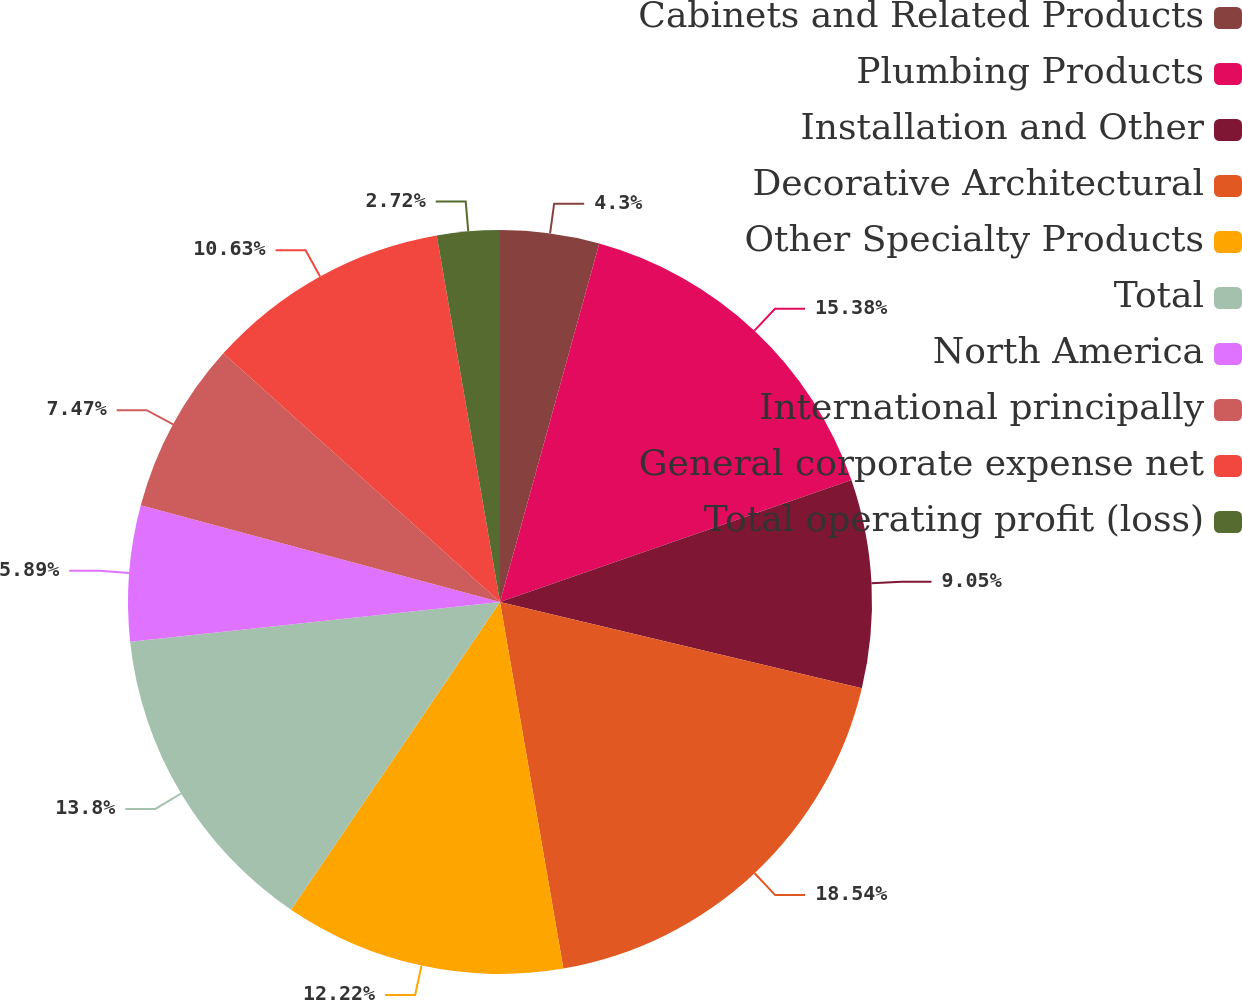Convert chart to OTSL. <chart><loc_0><loc_0><loc_500><loc_500><pie_chart><fcel>Cabinets and Related Products<fcel>Plumbing Products<fcel>Installation and Other<fcel>Decorative Architectural<fcel>Other Specialty Products<fcel>Total<fcel>North America<fcel>International principally<fcel>General corporate expense net<fcel>Total operating profit (loss)<nl><fcel>4.3%<fcel>15.38%<fcel>9.05%<fcel>18.55%<fcel>12.22%<fcel>13.8%<fcel>5.89%<fcel>7.47%<fcel>10.63%<fcel>2.72%<nl></chart> 